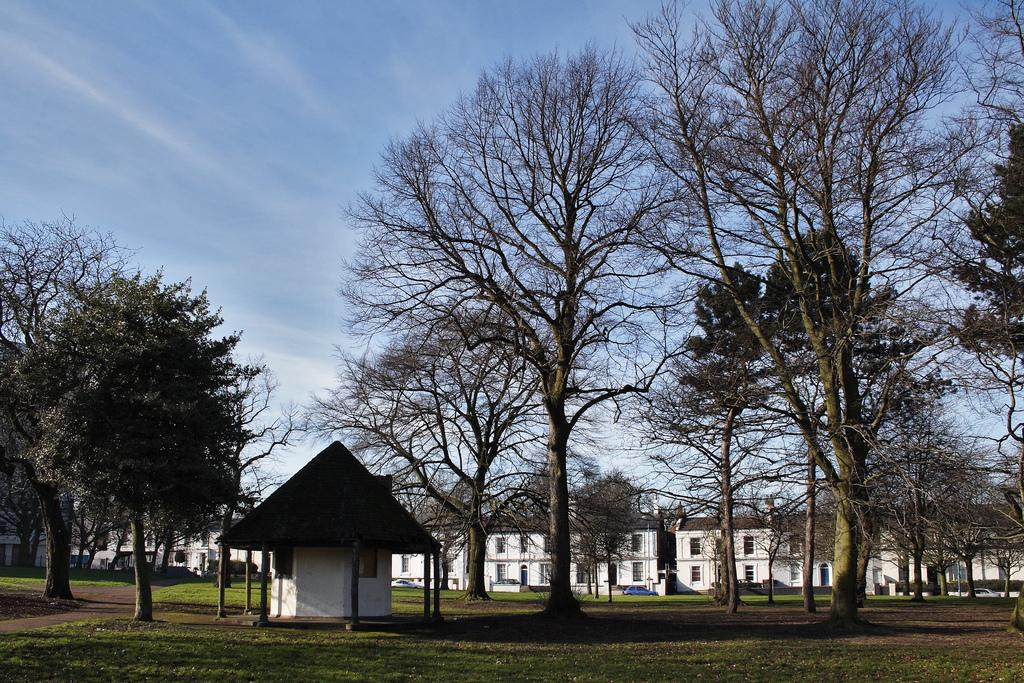What type of vegetation is present in the image? There are trees in the image. What type of structure can be seen with pillars? There is a shed with pillars in the image. What type of buildings are visible in the image? There are buildings with windows in the image. What is on the ground in the image? There is grass on the ground in the image. What is visible in the background of the image? There is sky visible in the background of the image. What can be seen in the sky? There are clouds in the sky. Where is the volleyball court located in the image? There is no volleyball court present in the image. How does the front of the shed move in the image? The front of the shed does not move in the image; it is stationary. 